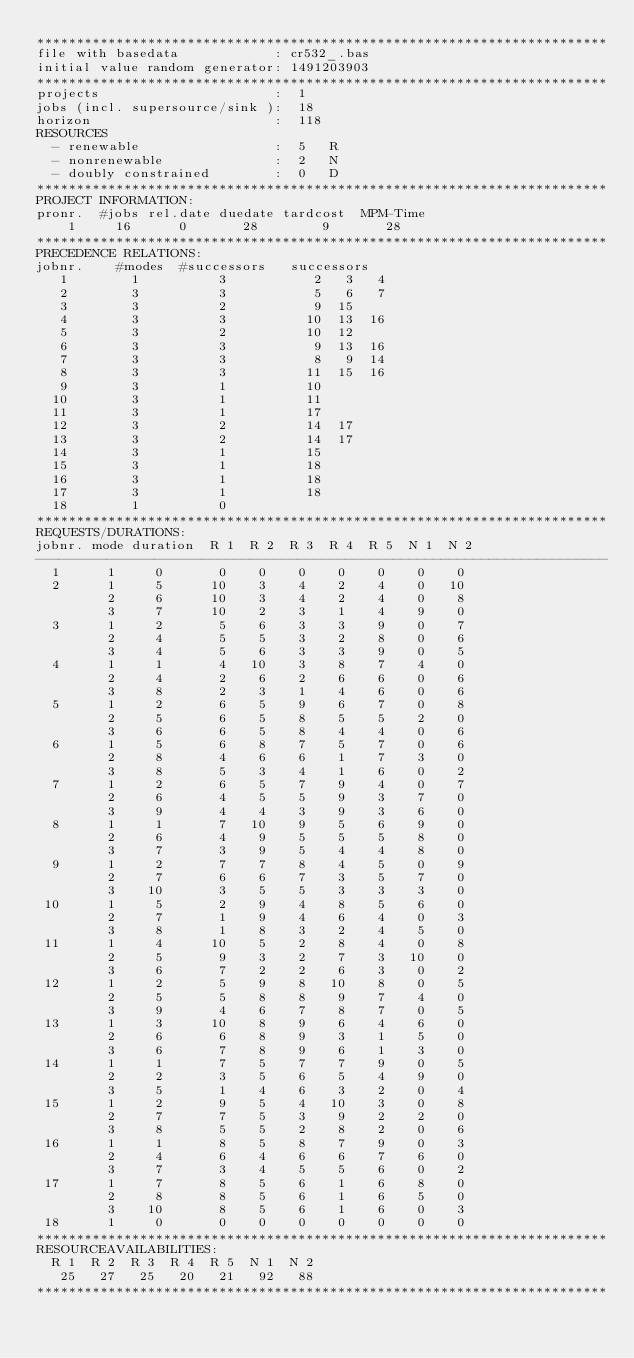<code> <loc_0><loc_0><loc_500><loc_500><_ObjectiveC_>************************************************************************
file with basedata            : cr532_.bas
initial value random generator: 1491203903
************************************************************************
projects                      :  1
jobs (incl. supersource/sink ):  18
horizon                       :  118
RESOURCES
  - renewable                 :  5   R
  - nonrenewable              :  2   N
  - doubly constrained        :  0   D
************************************************************************
PROJECT INFORMATION:
pronr.  #jobs rel.date duedate tardcost  MPM-Time
    1     16      0       28        9       28
************************************************************************
PRECEDENCE RELATIONS:
jobnr.    #modes  #successors   successors
   1        1          3           2   3   4
   2        3          3           5   6   7
   3        3          2           9  15
   4        3          3          10  13  16
   5        3          2          10  12
   6        3          3           9  13  16
   7        3          3           8   9  14
   8        3          3          11  15  16
   9        3          1          10
  10        3          1          11
  11        3          1          17
  12        3          2          14  17
  13        3          2          14  17
  14        3          1          15
  15        3          1          18
  16        3          1          18
  17        3          1          18
  18        1          0        
************************************************************************
REQUESTS/DURATIONS:
jobnr. mode duration  R 1  R 2  R 3  R 4  R 5  N 1  N 2
------------------------------------------------------------------------
  1      1     0       0    0    0    0    0    0    0
  2      1     5      10    3    4    2    4    0   10
         2     6      10    3    4    2    4    0    8
         3     7      10    2    3    1    4    9    0
  3      1     2       5    6    3    3    9    0    7
         2     4       5    5    3    2    8    0    6
         3     4       5    6    3    3    9    0    5
  4      1     1       4   10    3    8    7    4    0
         2     4       2    6    2    6    6    0    6
         3     8       2    3    1    4    6    0    6
  5      1     2       6    5    9    6    7    0    8
         2     5       6    5    8    5    5    2    0
         3     6       6    5    8    4    4    0    6
  6      1     5       6    8    7    5    7    0    6
         2     8       4    6    6    1    7    3    0
         3     8       5    3    4    1    6    0    2
  7      1     2       6    5    7    9    4    0    7
         2     6       4    5    5    9    3    7    0
         3     9       4    4    3    9    3    6    0
  8      1     1       7   10    9    5    6    9    0
         2     6       4    9    5    5    5    8    0
         3     7       3    9    5    4    4    8    0
  9      1     2       7    7    8    4    5    0    9
         2     7       6    6    7    3    5    7    0
         3    10       3    5    5    3    3    3    0
 10      1     5       2    9    4    8    5    6    0
         2     7       1    9    4    6    4    0    3
         3     8       1    8    3    2    4    5    0
 11      1     4      10    5    2    8    4    0    8
         2     5       9    3    2    7    3   10    0
         3     6       7    2    2    6    3    0    2
 12      1     2       5    9    8   10    8    0    5
         2     5       5    8    8    9    7    4    0
         3     9       4    6    7    8    7    0    5
 13      1     3      10    8    9    6    4    6    0
         2     6       6    8    9    3    1    5    0
         3     6       7    8    9    6    1    3    0
 14      1     1       7    5    7    7    9    0    5
         2     2       3    5    6    5    4    9    0
         3     5       1    4    6    3    2    0    4
 15      1     2       9    5    4   10    3    0    8
         2     7       7    5    3    9    2    2    0
         3     8       5    5    2    8    2    0    6
 16      1     1       8    5    8    7    9    0    3
         2     4       6    4    6    6    7    6    0
         3     7       3    4    5    5    6    0    2
 17      1     7       8    5    6    1    6    8    0
         2     8       8    5    6    1    6    5    0
         3    10       8    5    6    1    6    0    3
 18      1     0       0    0    0    0    0    0    0
************************************************************************
RESOURCEAVAILABILITIES:
  R 1  R 2  R 3  R 4  R 5  N 1  N 2
   25   27   25   20   21   92   88
************************************************************************
</code> 